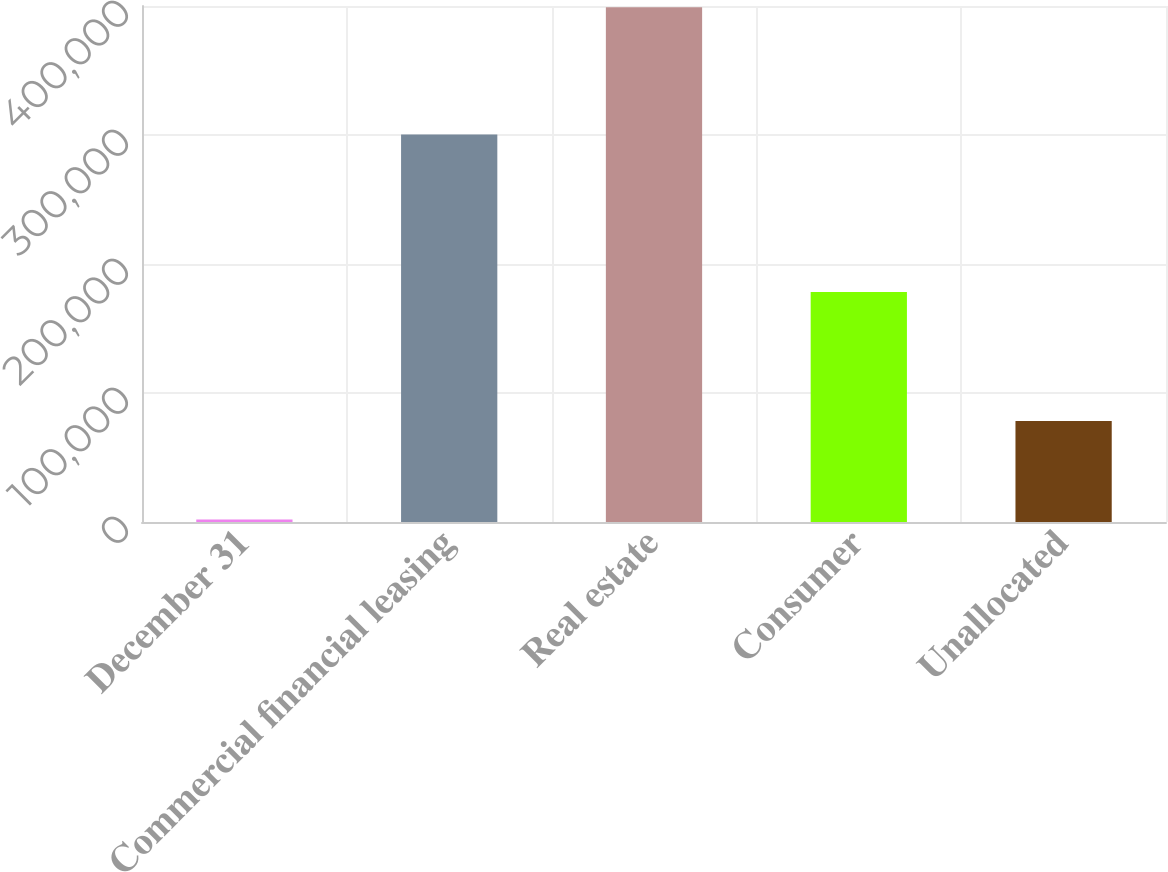Convert chart. <chart><loc_0><loc_0><loc_500><loc_500><bar_chart><fcel>December 31<fcel>Commercial financial leasing<fcel>Real estate<fcel>Consumer<fcel>Unallocated<nl><fcel>2015<fcel>300404<fcel>399069<fcel>178320<fcel>78199<nl></chart> 